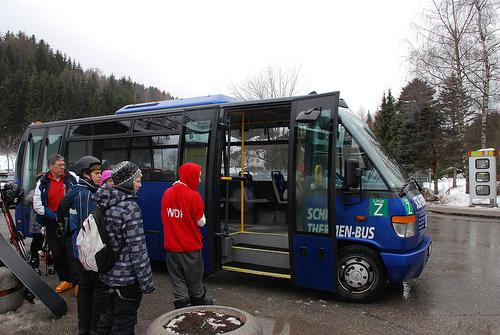Question: where was this photo taken?
Choices:
A. Train station.
B. Bus stop.
C. Subway station.
D. Airport.
Answer with the letter. Answer: B Question: what are the people doing?
Choices:
A. Washing the van.
B. Entering the van.
C. Cleaning out the van.
D. Putting gas in the van.
Answer with the letter. Answer: B Question: why are the people wearing heavy jackets?
Choices:
A. Because it's cold outside.
B. They are modeling winter jackets.
C. To feel warm.
D. They are trying on winter wear.
Answer with the letter. Answer: C Question: who are this?
Choices:
A. Friends.
B. People.
C. Co workers.
D. Family.
Answer with the letter. Answer: B Question: when was this?
Choices:
A. At night.
B. During a party.
C. After a swim meet.
D. Daytime.
Answer with the letter. Answer: D 